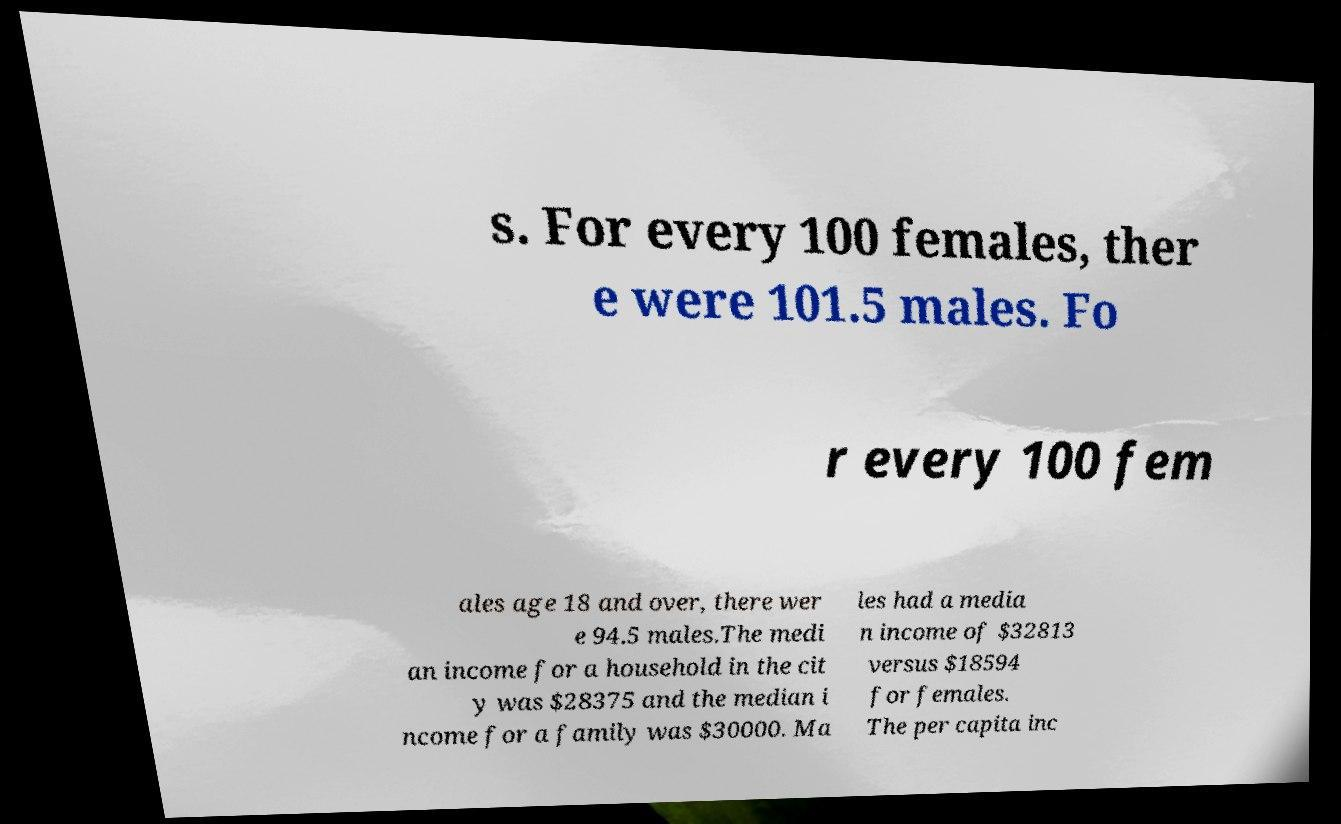I need the written content from this picture converted into text. Can you do that? s. For every 100 females, ther e were 101.5 males. Fo r every 100 fem ales age 18 and over, there wer e 94.5 males.The medi an income for a household in the cit y was $28375 and the median i ncome for a family was $30000. Ma les had a media n income of $32813 versus $18594 for females. The per capita inc 